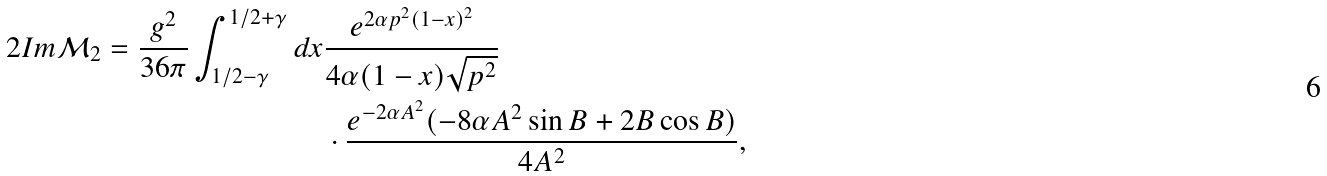<formula> <loc_0><loc_0><loc_500><loc_500>2 I m \mathcal { M } _ { 2 } = \frac { g ^ { 2 } } { 3 6 \pi } \int _ { 1 / 2 - \gamma } ^ { 1 / 2 + \gamma } d x & \frac { e ^ { 2 \alpha p ^ { 2 } ( 1 - x ) ^ { 2 } } } { 4 \alpha ( 1 - x ) \sqrt { p ^ { 2 } } } \\ & \cdot \frac { e ^ { - 2 \alpha A ^ { 2 } } ( - 8 \alpha A ^ { 2 } \sin B + 2 B \cos B ) } { 4 A ^ { 2 } } ,</formula> 